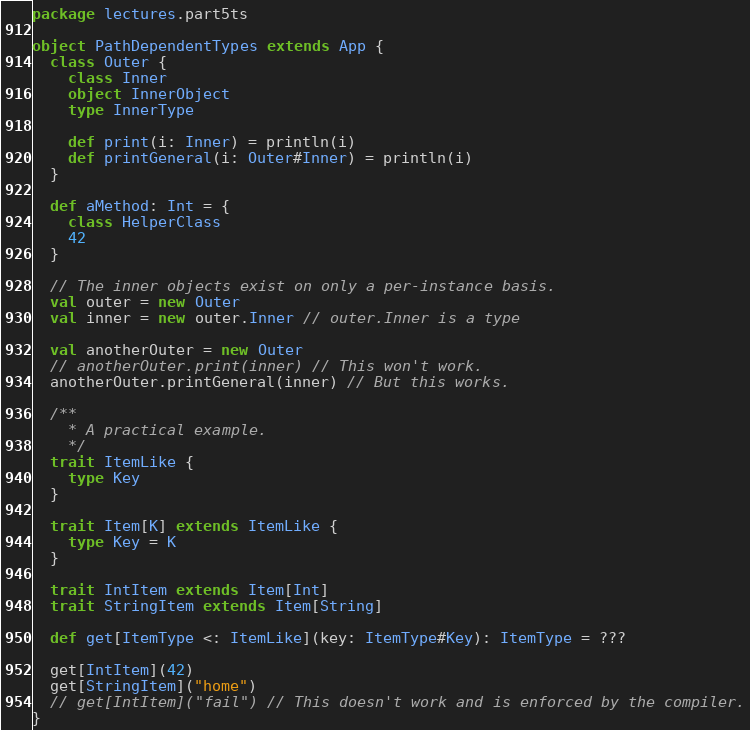<code> <loc_0><loc_0><loc_500><loc_500><_Scala_>package lectures.part5ts

object PathDependentTypes extends App {
  class Outer {
    class Inner
    object InnerObject
    type InnerType

    def print(i: Inner) = println(i)
    def printGeneral(i: Outer#Inner) = println(i)
  }

  def aMethod: Int = {
    class HelperClass
    42
  }

  // The inner objects exist on only a per-instance basis.
  val outer = new Outer
  val inner = new outer.Inner // outer.Inner is a type

  val anotherOuter = new Outer
  // anotherOuter.print(inner) // This won't work.
  anotherOuter.printGeneral(inner) // But this works.

  /**
    * A practical example.
    */
  trait ItemLike {
    type Key
  }

  trait Item[K] extends ItemLike {
    type Key = K
  }

  trait IntItem extends Item[Int]
  trait StringItem extends Item[String]

  def get[ItemType <: ItemLike](key: ItemType#Key): ItemType = ???

  get[IntItem](42)
  get[StringItem]("home")
  // get[IntItem]("fail") // This doesn't work and is enforced by the compiler.
}
</code> 